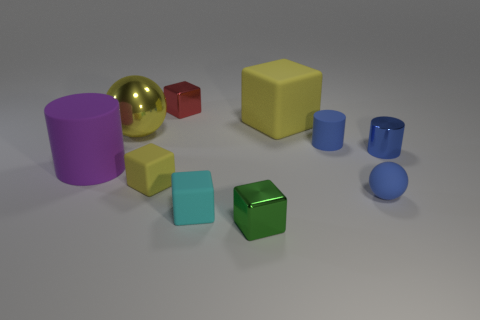Subtract all small cubes. How many cubes are left? 1 Subtract 1 cylinders. How many cylinders are left? 2 Subtract all cyan cubes. How many cubes are left? 4 Subtract all green cubes. Subtract all purple balls. How many cubes are left? 4 Subtract all spheres. How many objects are left? 8 Subtract 1 cyan cubes. How many objects are left? 9 Subtract all big red shiny objects. Subtract all cylinders. How many objects are left? 7 Add 7 tiny cyan rubber cubes. How many tiny cyan rubber cubes are left? 8 Add 8 large brown rubber cylinders. How many large brown rubber cylinders exist? 8 